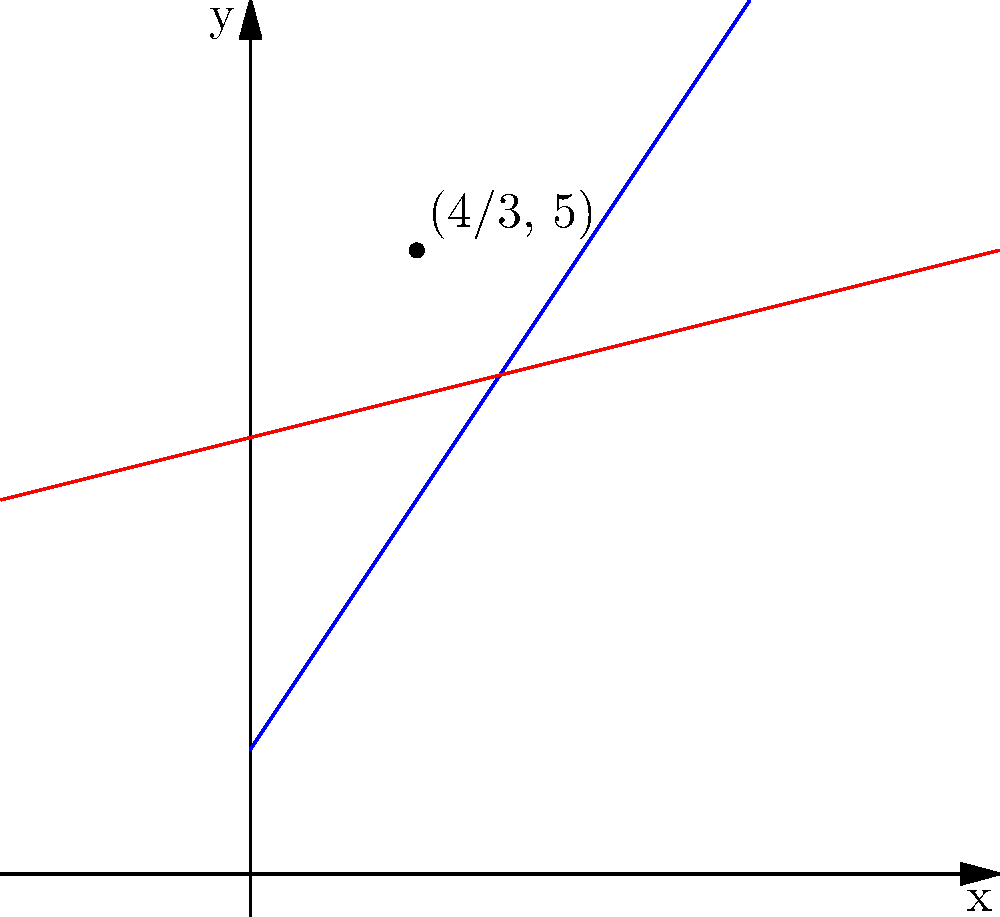In a multiplayer arena, two players are moving along linear trajectories. Player A's position is given by the equation $$(x,y) = (2t, 3t + 1)$$ and Player B's position is given by $$(x,y) = (4t - 2, t + 3)$$, where $t$ represents time. At what point $(x,y)$ do their paths intersect? To find the intersection point, we need to solve the system of equations:

1) Set the x-coordinates equal:
   $2t_1 = 4t_2 - 2$

2) Set the y-coordinates equal:
   $3t_1 + 1 = t_2 + 3$

3) Solve for $t_1$ in terms of $t_2$ using the y-equation:
   $t_1 = \frac{t_2 + 2}{3}$

4) Substitute this into the x-equation:
   $2(\frac{t_2 + 2}{3}) = 4t_2 - 2$
   $\frac{2t_2 + 4}{3} = 4t_2 - 2$

5) Multiply both sides by 3:
   $2t_2 + 4 = 12t_2 - 6$
   $10 = 10t_2$
   $t_2 = 1$

6) Substitute back to find $t_1$:
   $t_1 = \frac{1 + 2}{3} = 1$

7) Use either player's equation to find the intersection point:
   For Player A: $(x,y) = (2(1), 3(1) + 1) = (2, 4)$
   For Player B: $(x,y) = (4(1) - 2, 1 + 3) = (2, 4)$

Therefore, the paths intersect at the point (2, 4).
Answer: (2, 4) 